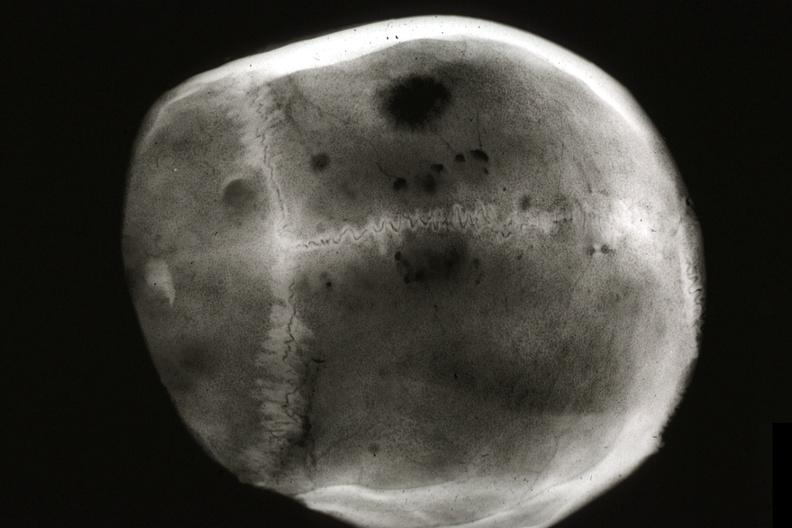s myoma lesion present?
Answer the question using a single word or phrase. No 